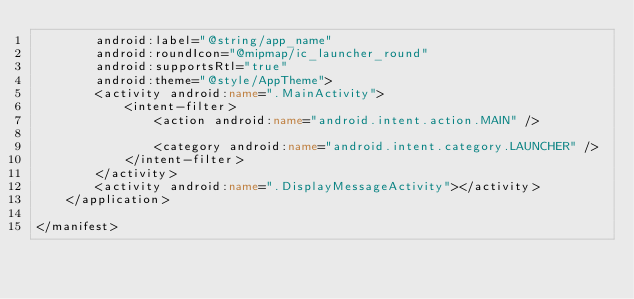<code> <loc_0><loc_0><loc_500><loc_500><_XML_>        android:label="@string/app_name"
        android:roundIcon="@mipmap/ic_launcher_round"
        android:supportsRtl="true"
        android:theme="@style/AppTheme">
        <activity android:name=".MainActivity">
            <intent-filter>
                <action android:name="android.intent.action.MAIN" />

                <category android:name="android.intent.category.LAUNCHER" />
            </intent-filter>
        </activity>
        <activity android:name=".DisplayMessageActivity"></activity>
    </application>

</manifest></code> 